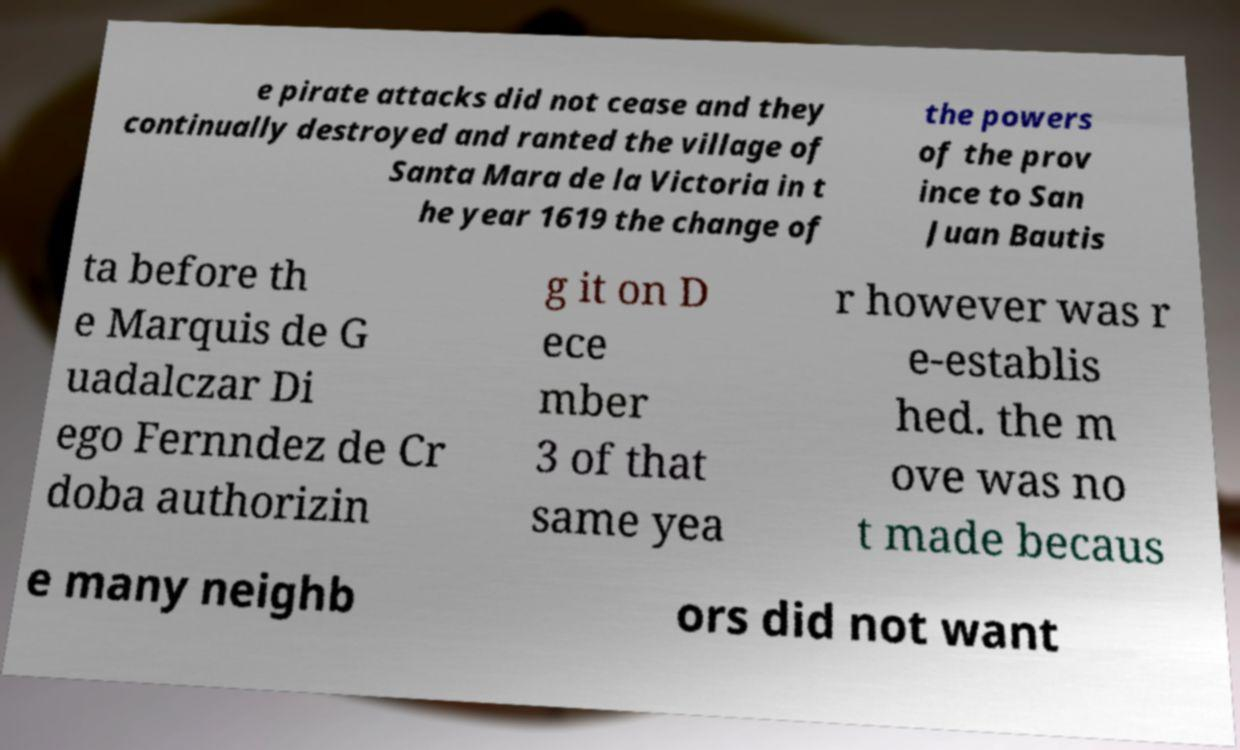For documentation purposes, I need the text within this image transcribed. Could you provide that? e pirate attacks did not cease and they continually destroyed and ranted the village of Santa Mara de la Victoria in t he year 1619 the change of the powers of the prov ince to San Juan Bautis ta before th e Marquis de G uadalczar Di ego Fernndez de Cr doba authorizin g it on D ece mber 3 of that same yea r however was r e-establis hed. the m ove was no t made becaus e many neighb ors did not want 